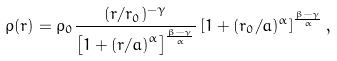Convert formula to latex. <formula><loc_0><loc_0><loc_500><loc_500>\rho ( r ) = \rho _ { 0 } \frac { ( r / r _ { 0 } ) ^ { - \gamma } } { \left [ 1 + \left ( r / a \right ) ^ { \alpha } \right ] ^ { \frac { \beta - \gamma } { \alpha } } } \left [ 1 + ( r _ { 0 } / a ) ^ { \alpha } \right ] ^ { \frac { \beta - \gamma } { \alpha } } ,</formula> 